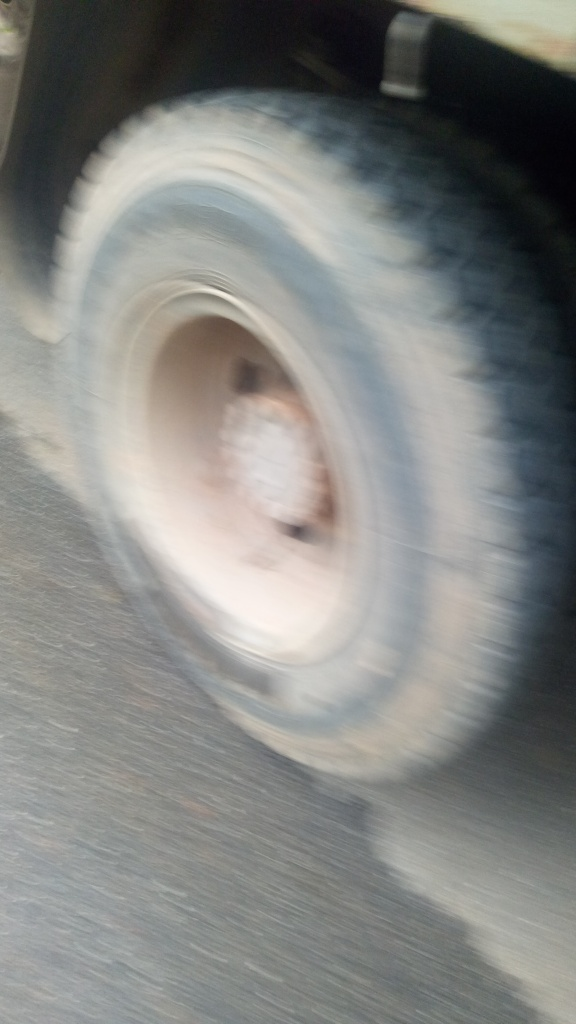Can you describe what you see in this image? Certainly! The image appears to capture a vehicle's tire in motion, creating a significant amount of motion blur. Because of this blur, no specific details can be discerned clearly. However, we can infer that the vehicle was likely moving at the time the photo was taken, as the radial streaking pattern is characteristic of motion blur associated with rotating objects. 